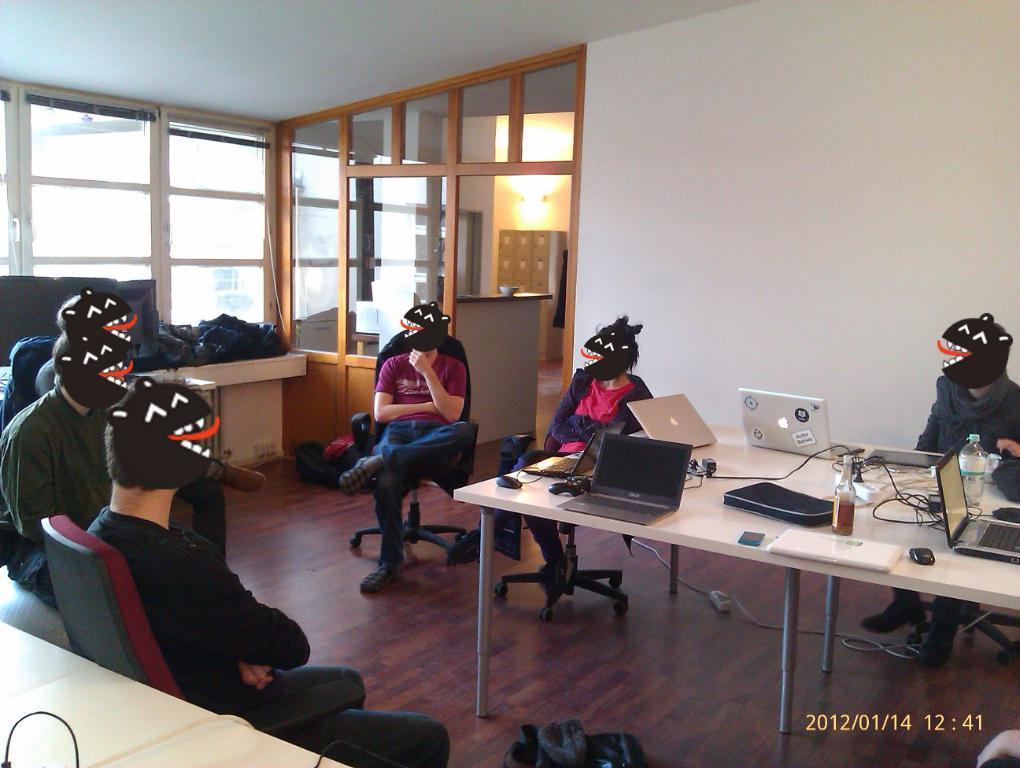Describe this image in one or two sentences. This is an edited image, in that, we can see a few people sitting on the chairs, there is a window, lockers, a bowl, a partition, and the wall, there is a table, on that table there are laptops, mouses, bottles, cell phone, wires, bags, papers, also we can see some bags on another table, there is an electrical socket. 